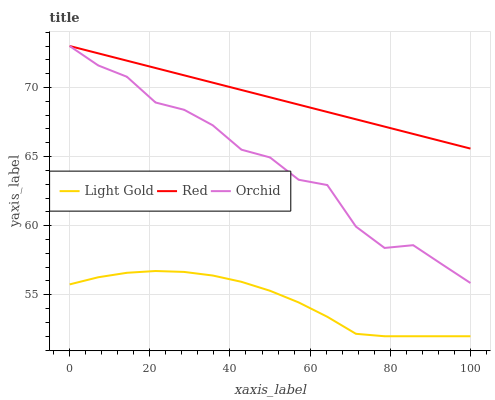Does Light Gold have the minimum area under the curve?
Answer yes or no. Yes. Does Red have the maximum area under the curve?
Answer yes or no. Yes. Does Orchid have the minimum area under the curve?
Answer yes or no. No. Does Orchid have the maximum area under the curve?
Answer yes or no. No. Is Red the smoothest?
Answer yes or no. Yes. Is Orchid the roughest?
Answer yes or no. Yes. Is Orchid the smoothest?
Answer yes or no. No. Is Red the roughest?
Answer yes or no. No. Does Light Gold have the lowest value?
Answer yes or no. Yes. Does Orchid have the lowest value?
Answer yes or no. No. Does Orchid have the highest value?
Answer yes or no. Yes. Is Light Gold less than Orchid?
Answer yes or no. Yes. Is Red greater than Light Gold?
Answer yes or no. Yes. Does Red intersect Orchid?
Answer yes or no. Yes. Is Red less than Orchid?
Answer yes or no. No. Is Red greater than Orchid?
Answer yes or no. No. Does Light Gold intersect Orchid?
Answer yes or no. No. 